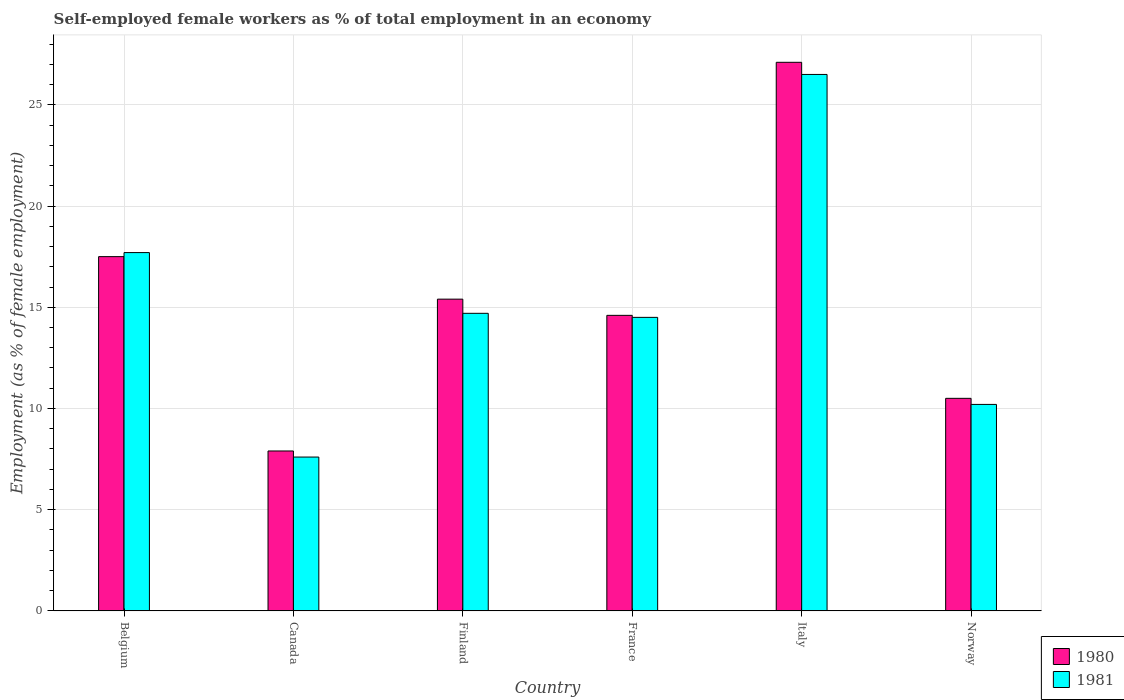Are the number of bars on each tick of the X-axis equal?
Make the answer very short. Yes. How many bars are there on the 2nd tick from the left?
Keep it short and to the point. 2. What is the label of the 2nd group of bars from the left?
Provide a short and direct response. Canada. In how many cases, is the number of bars for a given country not equal to the number of legend labels?
Provide a succinct answer. 0. Across all countries, what is the minimum percentage of self-employed female workers in 1981?
Provide a short and direct response. 7.6. In which country was the percentage of self-employed female workers in 1981 maximum?
Make the answer very short. Italy. What is the total percentage of self-employed female workers in 1981 in the graph?
Make the answer very short. 91.2. What is the difference between the percentage of self-employed female workers in 1981 in Belgium and that in Canada?
Keep it short and to the point. 10.1. What is the difference between the percentage of self-employed female workers in 1980 in Finland and the percentage of self-employed female workers in 1981 in Belgium?
Your response must be concise. -2.3. What is the average percentage of self-employed female workers in 1981 per country?
Offer a terse response. 15.2. What is the difference between the percentage of self-employed female workers of/in 1980 and percentage of self-employed female workers of/in 1981 in Canada?
Your answer should be very brief. 0.3. In how many countries, is the percentage of self-employed female workers in 1981 greater than 11 %?
Provide a short and direct response. 4. What is the ratio of the percentage of self-employed female workers in 1980 in Canada to that in Finland?
Offer a terse response. 0.51. Is the percentage of self-employed female workers in 1980 in Finland less than that in Italy?
Give a very brief answer. Yes. Is the difference between the percentage of self-employed female workers in 1980 in Italy and Norway greater than the difference between the percentage of self-employed female workers in 1981 in Italy and Norway?
Your response must be concise. Yes. What is the difference between the highest and the second highest percentage of self-employed female workers in 1981?
Ensure brevity in your answer.  -8.8. What is the difference between the highest and the lowest percentage of self-employed female workers in 1980?
Offer a very short reply. 19.2. In how many countries, is the percentage of self-employed female workers in 1981 greater than the average percentage of self-employed female workers in 1981 taken over all countries?
Provide a succinct answer. 2. Is the sum of the percentage of self-employed female workers in 1981 in Canada and Finland greater than the maximum percentage of self-employed female workers in 1980 across all countries?
Your answer should be very brief. No. What does the 1st bar from the right in Norway represents?
Ensure brevity in your answer.  1981. How many bars are there?
Your response must be concise. 12. Are all the bars in the graph horizontal?
Offer a very short reply. No. Does the graph contain any zero values?
Your answer should be very brief. No. Does the graph contain grids?
Your response must be concise. Yes. Where does the legend appear in the graph?
Your answer should be very brief. Bottom right. What is the title of the graph?
Offer a terse response. Self-employed female workers as % of total employment in an economy. What is the label or title of the Y-axis?
Provide a short and direct response. Employment (as % of female employment). What is the Employment (as % of female employment) of 1981 in Belgium?
Give a very brief answer. 17.7. What is the Employment (as % of female employment) in 1980 in Canada?
Offer a terse response. 7.9. What is the Employment (as % of female employment) of 1981 in Canada?
Provide a succinct answer. 7.6. What is the Employment (as % of female employment) in 1980 in Finland?
Ensure brevity in your answer.  15.4. What is the Employment (as % of female employment) of 1981 in Finland?
Offer a very short reply. 14.7. What is the Employment (as % of female employment) in 1980 in France?
Offer a terse response. 14.6. What is the Employment (as % of female employment) of 1980 in Italy?
Make the answer very short. 27.1. What is the Employment (as % of female employment) of 1981 in Norway?
Make the answer very short. 10.2. Across all countries, what is the maximum Employment (as % of female employment) in 1980?
Give a very brief answer. 27.1. Across all countries, what is the maximum Employment (as % of female employment) of 1981?
Offer a very short reply. 26.5. Across all countries, what is the minimum Employment (as % of female employment) in 1980?
Provide a short and direct response. 7.9. Across all countries, what is the minimum Employment (as % of female employment) in 1981?
Your response must be concise. 7.6. What is the total Employment (as % of female employment) of 1980 in the graph?
Your answer should be very brief. 93. What is the total Employment (as % of female employment) in 1981 in the graph?
Ensure brevity in your answer.  91.2. What is the difference between the Employment (as % of female employment) of 1980 in Belgium and that in Canada?
Your answer should be very brief. 9.6. What is the difference between the Employment (as % of female employment) of 1981 in Belgium and that in Canada?
Give a very brief answer. 10.1. What is the difference between the Employment (as % of female employment) in 1981 in Belgium and that in France?
Give a very brief answer. 3.2. What is the difference between the Employment (as % of female employment) in 1981 in Canada and that in Finland?
Your answer should be compact. -7.1. What is the difference between the Employment (as % of female employment) of 1981 in Canada and that in France?
Your answer should be very brief. -6.9. What is the difference between the Employment (as % of female employment) of 1980 in Canada and that in Italy?
Your answer should be very brief. -19.2. What is the difference between the Employment (as % of female employment) in 1981 in Canada and that in Italy?
Your answer should be compact. -18.9. What is the difference between the Employment (as % of female employment) in 1980 in Finland and that in France?
Give a very brief answer. 0.8. What is the difference between the Employment (as % of female employment) of 1981 in Finland and that in France?
Give a very brief answer. 0.2. What is the difference between the Employment (as % of female employment) in 1980 in Finland and that in Italy?
Your answer should be very brief. -11.7. What is the difference between the Employment (as % of female employment) in 1980 in Finland and that in Norway?
Provide a succinct answer. 4.9. What is the difference between the Employment (as % of female employment) of 1981 in France and that in Italy?
Offer a terse response. -12. What is the difference between the Employment (as % of female employment) in 1980 in France and that in Norway?
Keep it short and to the point. 4.1. What is the difference between the Employment (as % of female employment) in 1981 in France and that in Norway?
Give a very brief answer. 4.3. What is the difference between the Employment (as % of female employment) in 1980 in Italy and that in Norway?
Provide a short and direct response. 16.6. What is the difference between the Employment (as % of female employment) in 1981 in Italy and that in Norway?
Keep it short and to the point. 16.3. What is the difference between the Employment (as % of female employment) of 1980 in Belgium and the Employment (as % of female employment) of 1981 in Italy?
Offer a very short reply. -9. What is the difference between the Employment (as % of female employment) of 1980 in Belgium and the Employment (as % of female employment) of 1981 in Norway?
Your answer should be very brief. 7.3. What is the difference between the Employment (as % of female employment) of 1980 in Canada and the Employment (as % of female employment) of 1981 in Finland?
Make the answer very short. -6.8. What is the difference between the Employment (as % of female employment) in 1980 in Canada and the Employment (as % of female employment) in 1981 in France?
Your answer should be compact. -6.6. What is the difference between the Employment (as % of female employment) of 1980 in Canada and the Employment (as % of female employment) of 1981 in Italy?
Your response must be concise. -18.6. What is the difference between the Employment (as % of female employment) of 1980 in Finland and the Employment (as % of female employment) of 1981 in France?
Ensure brevity in your answer.  0.9. What is the difference between the Employment (as % of female employment) of 1980 in Finland and the Employment (as % of female employment) of 1981 in Norway?
Ensure brevity in your answer.  5.2. What is the difference between the Employment (as % of female employment) in 1980 and Employment (as % of female employment) in 1981 in Canada?
Provide a succinct answer. 0.3. What is the difference between the Employment (as % of female employment) in 1980 and Employment (as % of female employment) in 1981 in Italy?
Make the answer very short. 0.6. What is the ratio of the Employment (as % of female employment) in 1980 in Belgium to that in Canada?
Make the answer very short. 2.22. What is the ratio of the Employment (as % of female employment) of 1981 in Belgium to that in Canada?
Your answer should be compact. 2.33. What is the ratio of the Employment (as % of female employment) of 1980 in Belgium to that in Finland?
Offer a very short reply. 1.14. What is the ratio of the Employment (as % of female employment) of 1981 in Belgium to that in Finland?
Offer a terse response. 1.2. What is the ratio of the Employment (as % of female employment) of 1980 in Belgium to that in France?
Provide a short and direct response. 1.2. What is the ratio of the Employment (as % of female employment) in 1981 in Belgium to that in France?
Make the answer very short. 1.22. What is the ratio of the Employment (as % of female employment) in 1980 in Belgium to that in Italy?
Ensure brevity in your answer.  0.65. What is the ratio of the Employment (as % of female employment) in 1981 in Belgium to that in Italy?
Provide a short and direct response. 0.67. What is the ratio of the Employment (as % of female employment) of 1981 in Belgium to that in Norway?
Offer a very short reply. 1.74. What is the ratio of the Employment (as % of female employment) in 1980 in Canada to that in Finland?
Make the answer very short. 0.51. What is the ratio of the Employment (as % of female employment) of 1981 in Canada to that in Finland?
Give a very brief answer. 0.52. What is the ratio of the Employment (as % of female employment) in 1980 in Canada to that in France?
Offer a very short reply. 0.54. What is the ratio of the Employment (as % of female employment) in 1981 in Canada to that in France?
Make the answer very short. 0.52. What is the ratio of the Employment (as % of female employment) in 1980 in Canada to that in Italy?
Provide a short and direct response. 0.29. What is the ratio of the Employment (as % of female employment) in 1981 in Canada to that in Italy?
Offer a terse response. 0.29. What is the ratio of the Employment (as % of female employment) in 1980 in Canada to that in Norway?
Provide a short and direct response. 0.75. What is the ratio of the Employment (as % of female employment) of 1981 in Canada to that in Norway?
Your answer should be compact. 0.75. What is the ratio of the Employment (as % of female employment) in 1980 in Finland to that in France?
Make the answer very short. 1.05. What is the ratio of the Employment (as % of female employment) in 1981 in Finland to that in France?
Offer a very short reply. 1.01. What is the ratio of the Employment (as % of female employment) of 1980 in Finland to that in Italy?
Offer a terse response. 0.57. What is the ratio of the Employment (as % of female employment) of 1981 in Finland to that in Italy?
Your answer should be compact. 0.55. What is the ratio of the Employment (as % of female employment) of 1980 in Finland to that in Norway?
Provide a short and direct response. 1.47. What is the ratio of the Employment (as % of female employment) of 1981 in Finland to that in Norway?
Your answer should be compact. 1.44. What is the ratio of the Employment (as % of female employment) in 1980 in France to that in Italy?
Offer a terse response. 0.54. What is the ratio of the Employment (as % of female employment) in 1981 in France to that in Italy?
Offer a terse response. 0.55. What is the ratio of the Employment (as % of female employment) in 1980 in France to that in Norway?
Your response must be concise. 1.39. What is the ratio of the Employment (as % of female employment) of 1981 in France to that in Norway?
Provide a succinct answer. 1.42. What is the ratio of the Employment (as % of female employment) of 1980 in Italy to that in Norway?
Make the answer very short. 2.58. What is the ratio of the Employment (as % of female employment) in 1981 in Italy to that in Norway?
Offer a terse response. 2.6. What is the difference between the highest and the lowest Employment (as % of female employment) in 1980?
Your answer should be very brief. 19.2. 